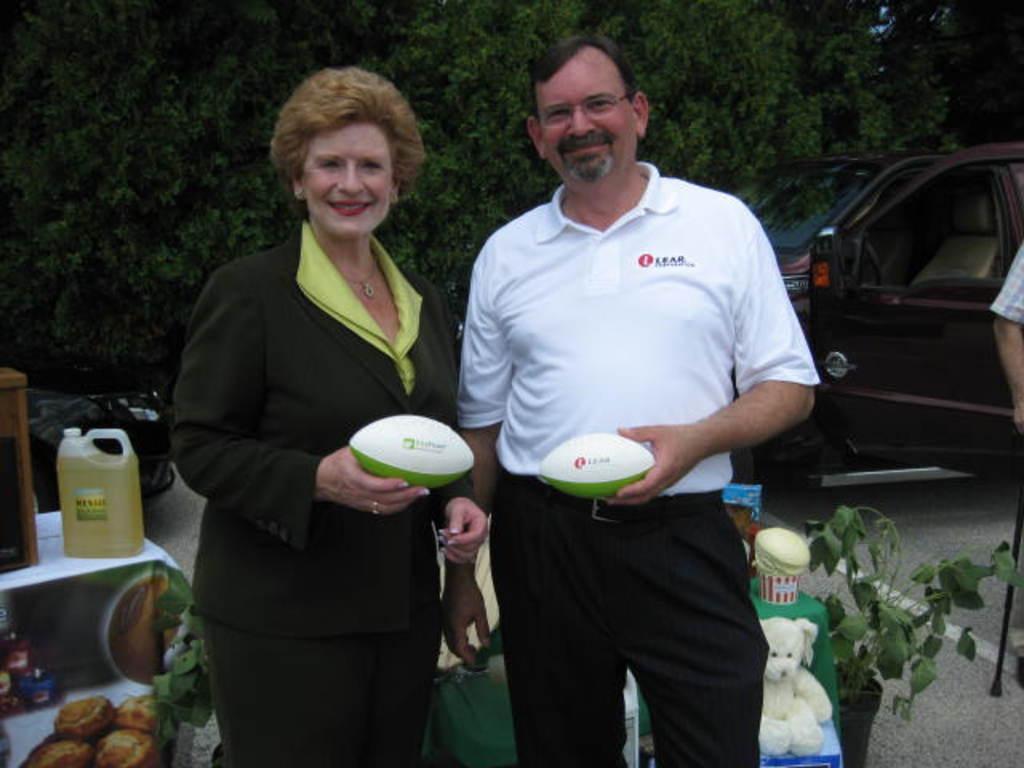Please provide a concise description of this image. This image is taken in outdoors, there are three people in this image. In the middle of the image a man and a woman are standing holding a ball in their hands. At the background there are few trees and a car. In the right side of the image there is a plant with a pot and a teddy bear on a table. 